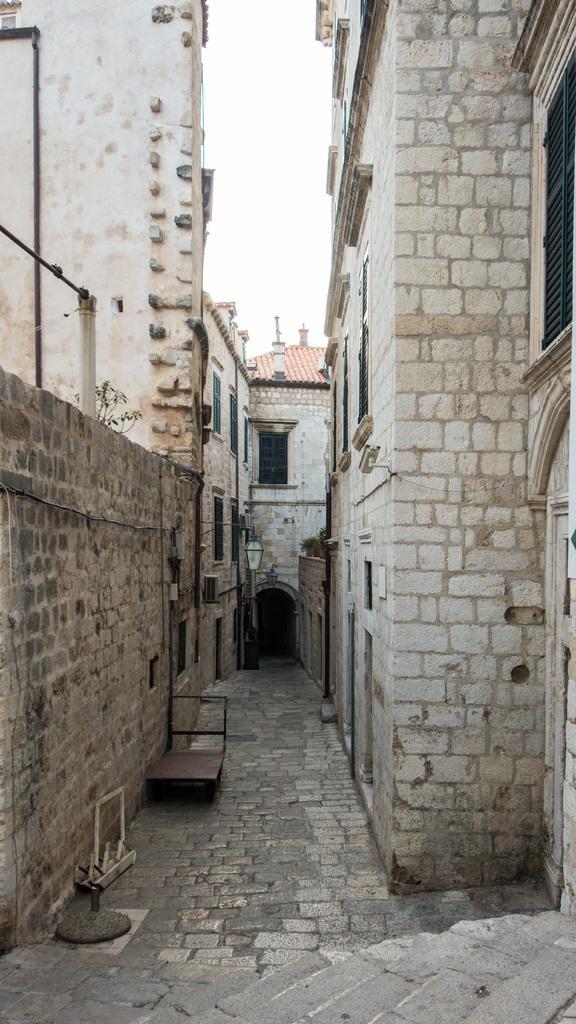Can you describe this image briefly? In this image I can see few buildings, windows and the trolley. In the background the sky is in white color. 